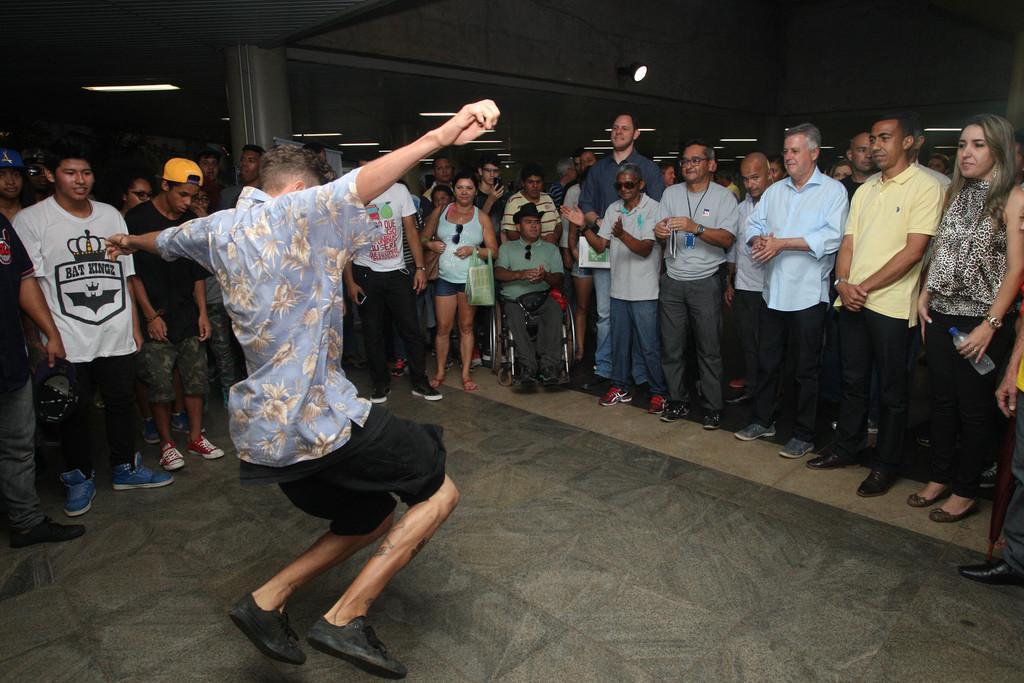In one or two sentences, can you explain what this image depicts? In this image we can see a person wearing blue color floral shirt, black color short, shoes dancing on the floor and there are some persons standing around him and cheering and in the background of the image there is a wall and lights. 